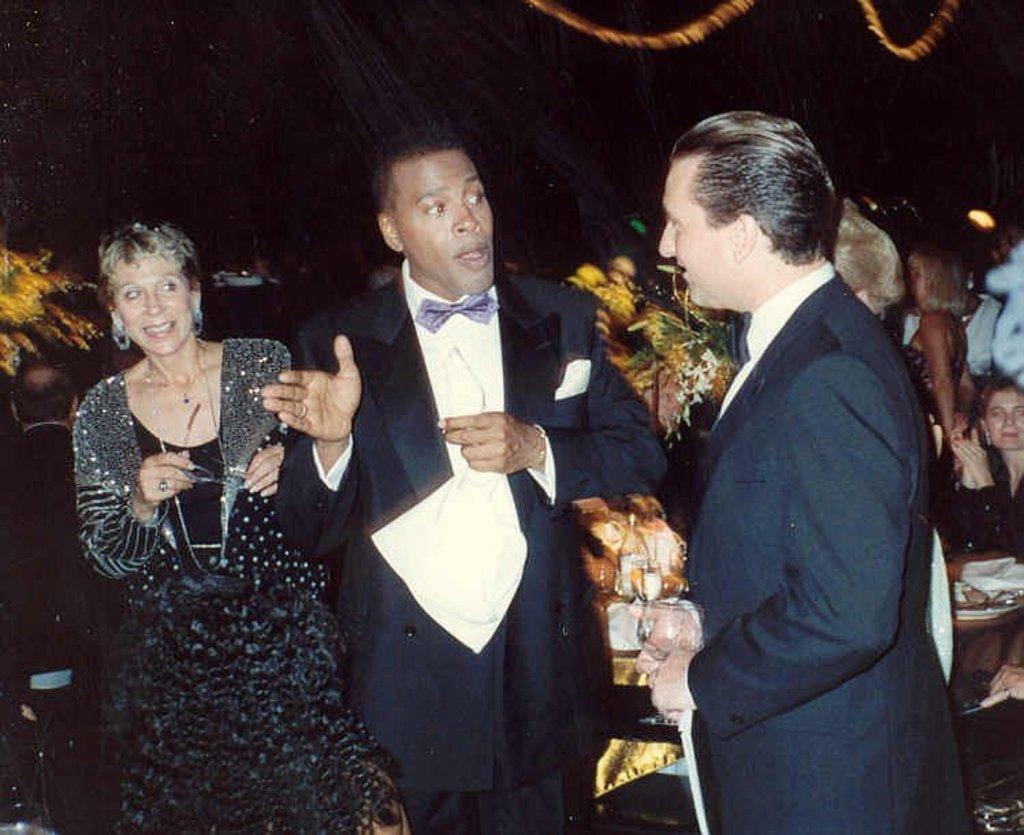Can you describe this image briefly? In the image we can see in front there are people standing and the men are wearing suit. Behind there are other people sitting on the chair. 